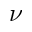Convert formula to latex. <formula><loc_0><loc_0><loc_500><loc_500>\nu</formula> 